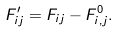Convert formula to latex. <formula><loc_0><loc_0><loc_500><loc_500>F ^ { \prime } _ { i j } = F _ { i j } - F ^ { 0 } _ { i , j } .</formula> 